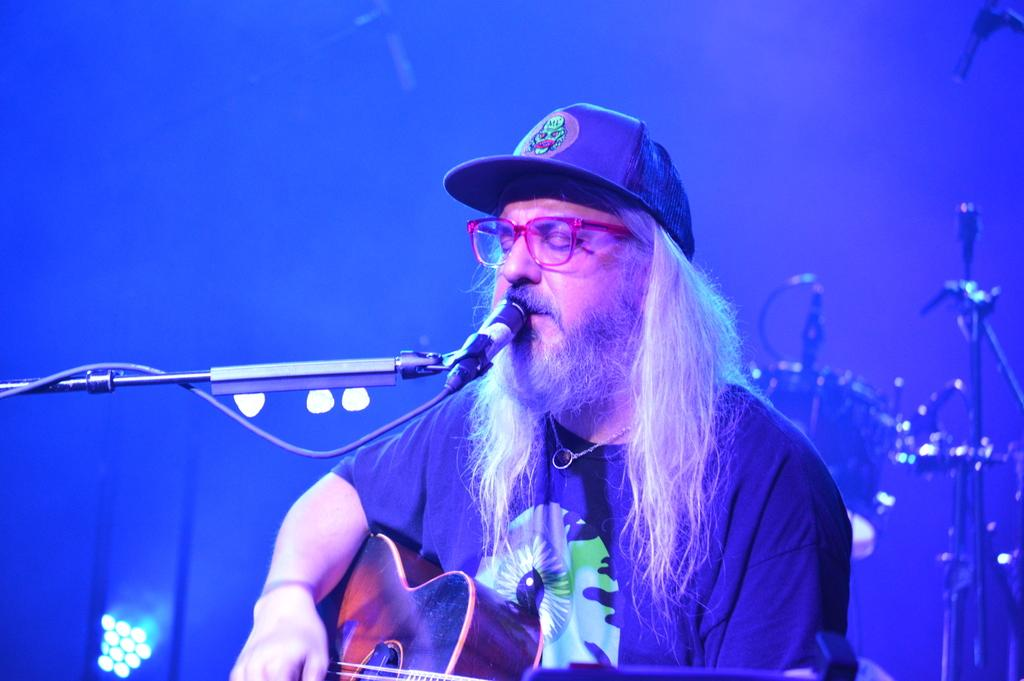What is the man in the image doing? The man is playing the guitar and singing through a microphone. How is the man playing the guitar? The man is using his hand to play the guitar. Where is the microphone positioned in relation to the man? The microphone is in front of the man. What can be seen in the background of the image? There are lights and drums in the background of the image. Can you see a shelf with water and a net in the image? No, there is no shelf, water, or net present in the image. 